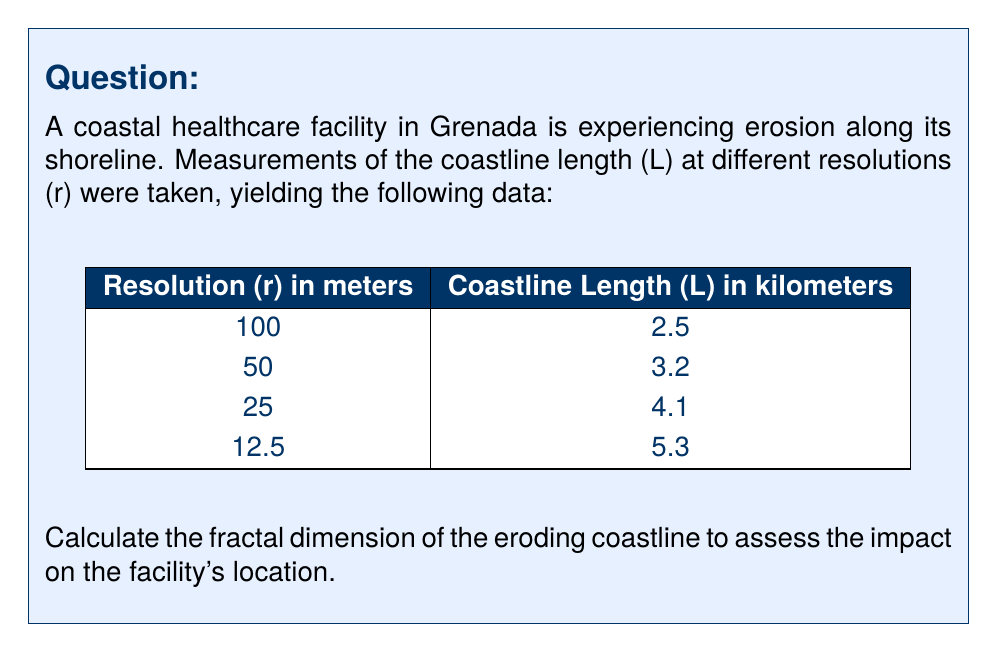Can you solve this math problem? To determine the fractal dimension of the coastline, we'll use the box-counting method, which is based on the relationship:

$$ L \propto r^{1-D} $$

Where L is the measured length, r is the resolution, and D is the fractal dimension.

Steps to solve:

1) Take the logarithm of both sides:
   $$ \log(L) = (1-D)\log(r) + \log(k) $$
   This is in the form of y = mx + b, where m = 1-D

2) Plot log(L) vs log(r):
   
[asy]
import graph;
size(200,200);
real[] x = {log(100)/log(10), log(50)/log(10), log(25)/log(10), log(12.5)/log(10)};
real[] y = {log(2.5)/log(10), log(3.2)/log(10), log(4.1)/log(10), log(5.3)/log(10)};
dot(x,y);
xaxis("log(r)",BottomTop,LeftTicks);
yaxis("log(L)",LeftRight,RightTicks);
draw(graph(x,y));
[/asy]

3) Calculate the slope (m) of this line using linear regression:
   $$ m = \frac{n\sum(xy) - \sum x \sum y}{n\sum x^2 - (\sum x)^2} $$
   
   Where x = log(r) and y = log(L)

4) After calculation, we get m ≈ -0.2726

5) Since m = 1-D, we can find D:
   $$ D = 1 - m = 1 - (-0.2726) = 1.2726 $$

The fractal dimension D is approximately 1.2726.
Answer: 1.2726 